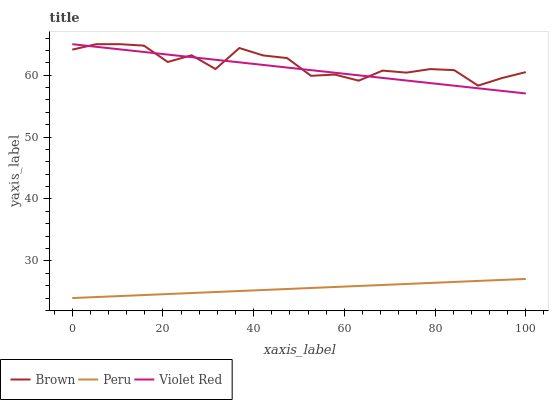Does Peru have the minimum area under the curve?
Answer yes or no. Yes. Does Brown have the maximum area under the curve?
Answer yes or no. Yes. Does Violet Red have the minimum area under the curve?
Answer yes or no. No. Does Violet Red have the maximum area under the curve?
Answer yes or no. No. Is Peru the smoothest?
Answer yes or no. Yes. Is Brown the roughest?
Answer yes or no. Yes. Is Violet Red the smoothest?
Answer yes or no. No. Is Violet Red the roughest?
Answer yes or no. No. Does Peru have the lowest value?
Answer yes or no. Yes. Does Violet Red have the lowest value?
Answer yes or no. No. Does Violet Red have the highest value?
Answer yes or no. Yes. Does Peru have the highest value?
Answer yes or no. No. Is Peru less than Violet Red?
Answer yes or no. Yes. Is Violet Red greater than Peru?
Answer yes or no. Yes. Does Violet Red intersect Brown?
Answer yes or no. Yes. Is Violet Red less than Brown?
Answer yes or no. No. Is Violet Red greater than Brown?
Answer yes or no. No. Does Peru intersect Violet Red?
Answer yes or no. No. 